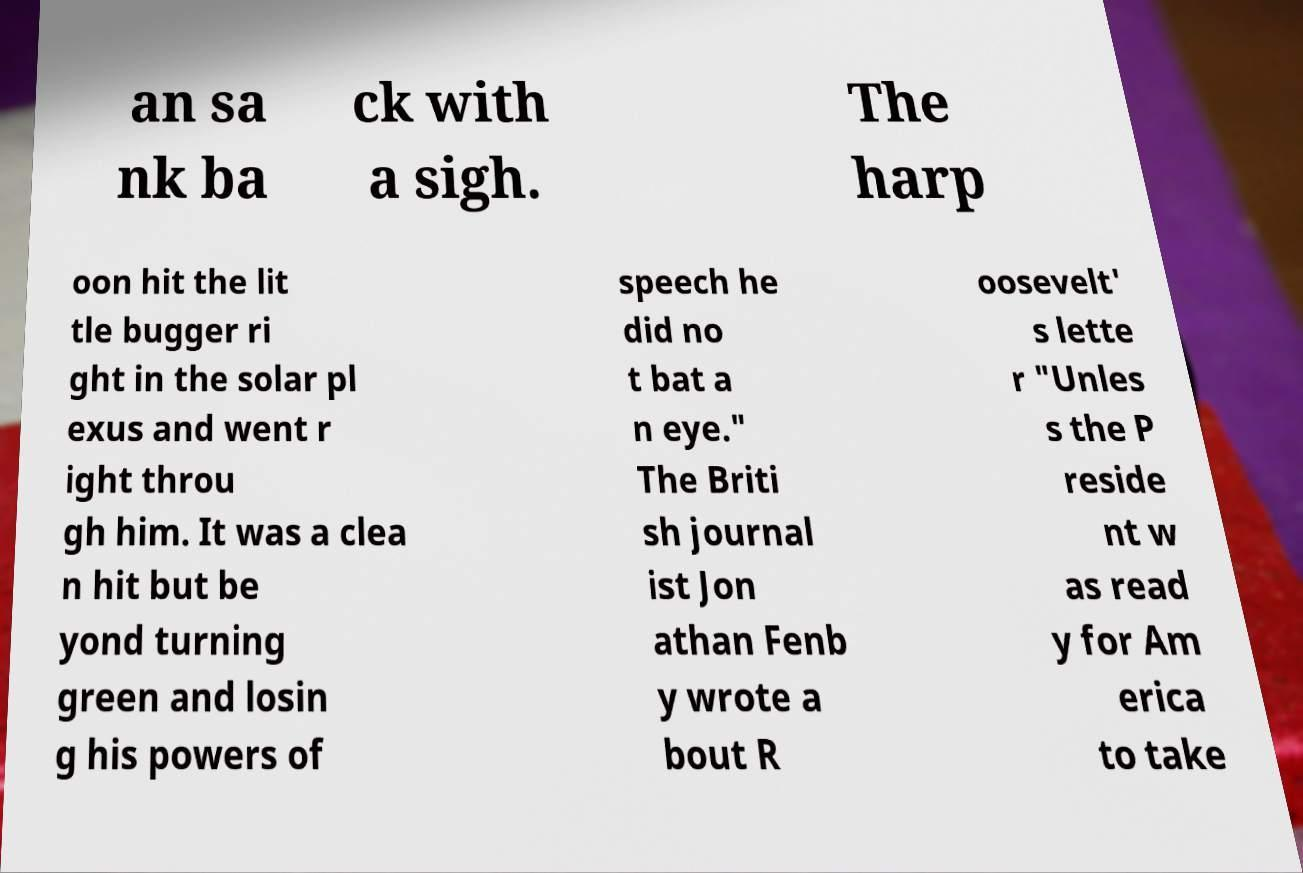What messages or text are displayed in this image? I need them in a readable, typed format. an sa nk ba ck with a sigh. The harp oon hit the lit tle bugger ri ght in the solar pl exus and went r ight throu gh him. It was a clea n hit but be yond turning green and losin g his powers of speech he did no t bat a n eye." The Briti sh journal ist Jon athan Fenb y wrote a bout R oosevelt' s lette r "Unles s the P reside nt w as read y for Am erica to take 